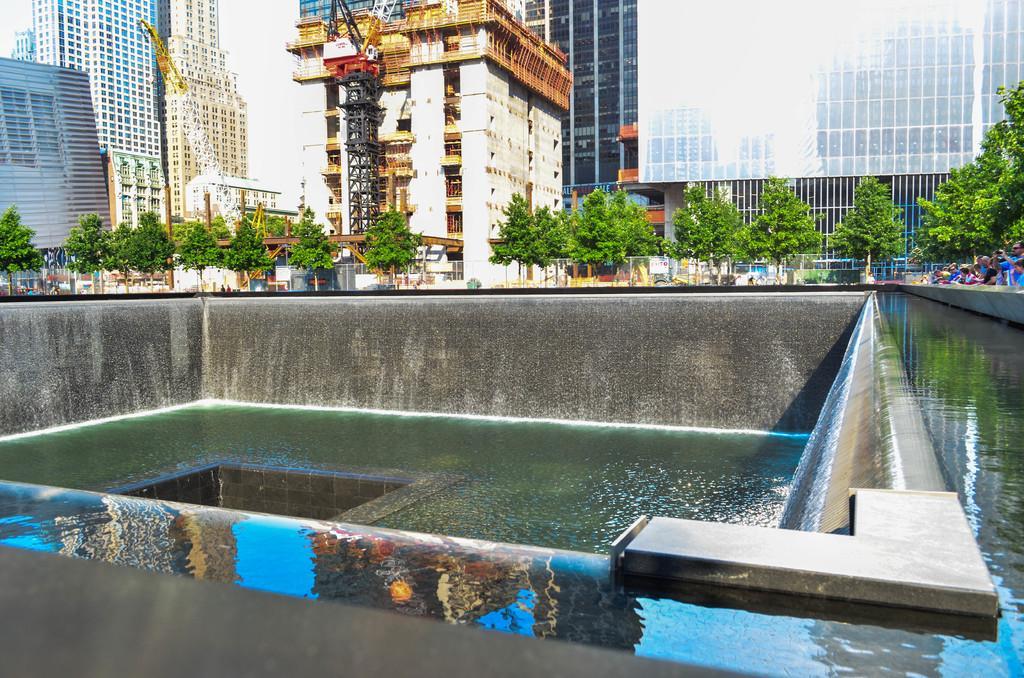Could you give a brief overview of what you see in this image? This is an outside view. At the bottom there is a fountain. In the background there are many trees and buildings. On the right side there are few people. 